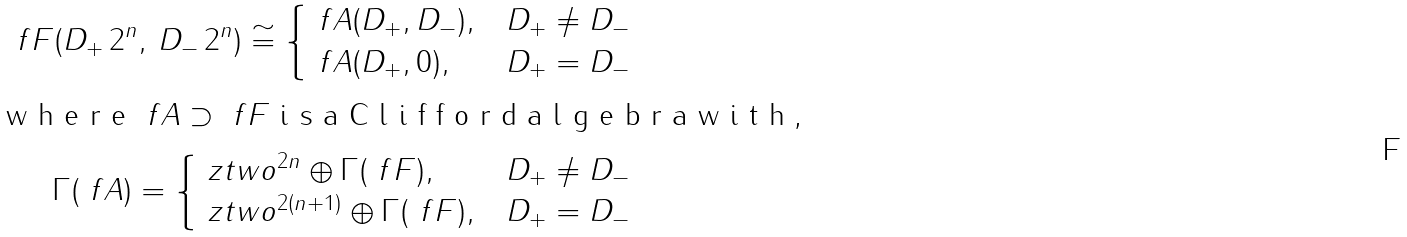<formula> <loc_0><loc_0><loc_500><loc_500>\ f F ( D _ { + } \, 2 ^ { n } , \, D _ { - } \, 2 ^ { n } ) \cong \begin{cases} \ f A ( D _ { + } , D _ { - } ) , & D _ { + } \ne D _ { - } \\ \ f A ( D _ { + } , 0 ) , & D _ { + } = D _ { - } \end{cases} \\ \intertext { w h e r e $ \ f A \supset \ f F $ i s a C l i f f o r d a l g e b r a w i t h , } \Gamma ( \ f A ) = \begin{cases} \ z t w o ^ { 2 n } \oplus \Gamma ( \ f F ) , & D _ { + } \ne D _ { - } \\ \ z t w o ^ { 2 ( n + 1 ) } \oplus \Gamma ( \ f F ) , & D _ { + } = D _ { - } \\ \end{cases}</formula> 